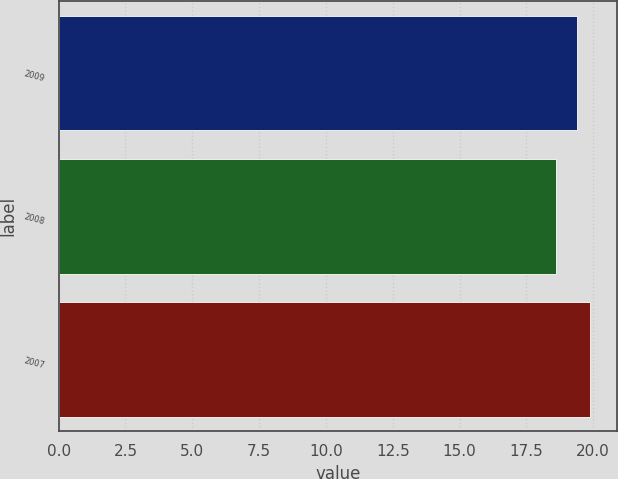Convert chart to OTSL. <chart><loc_0><loc_0><loc_500><loc_500><bar_chart><fcel>2009<fcel>2008<fcel>2007<nl><fcel>19.4<fcel>18.6<fcel>19.9<nl></chart> 